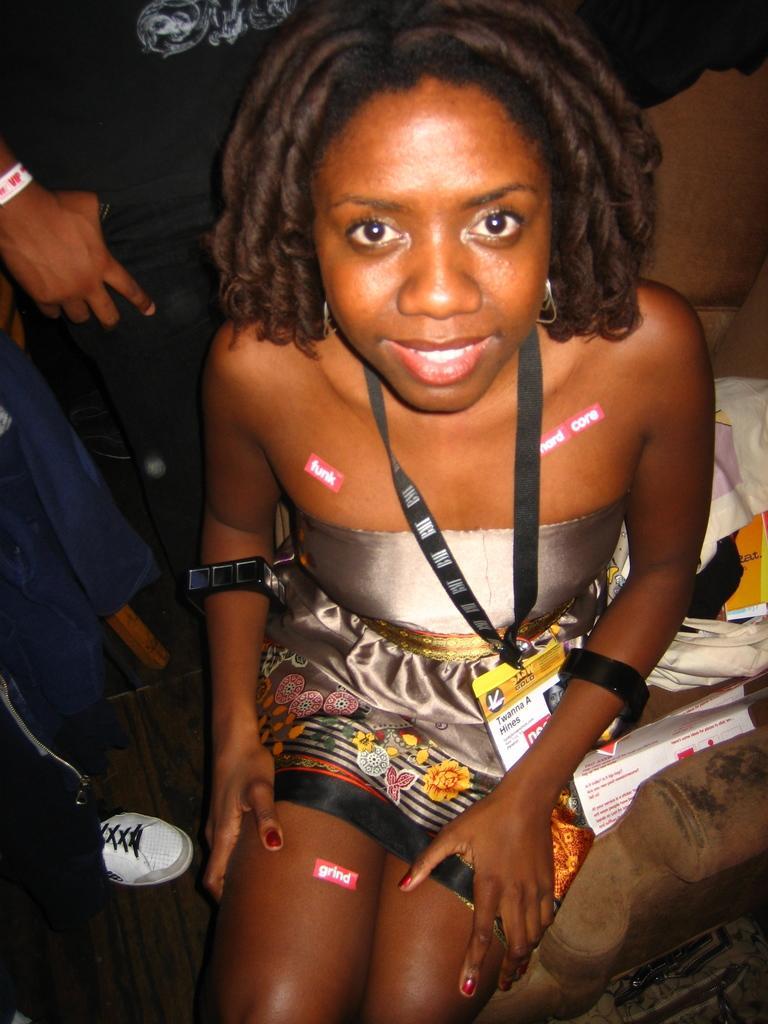In one or two sentences, can you explain what this image depicts? In this image I can see a woman sitting on a chair, smiling and giving pose for the picture. Beside her there are some papers and a white color cloth are placed. On the left side, I can see two persons are standing. 